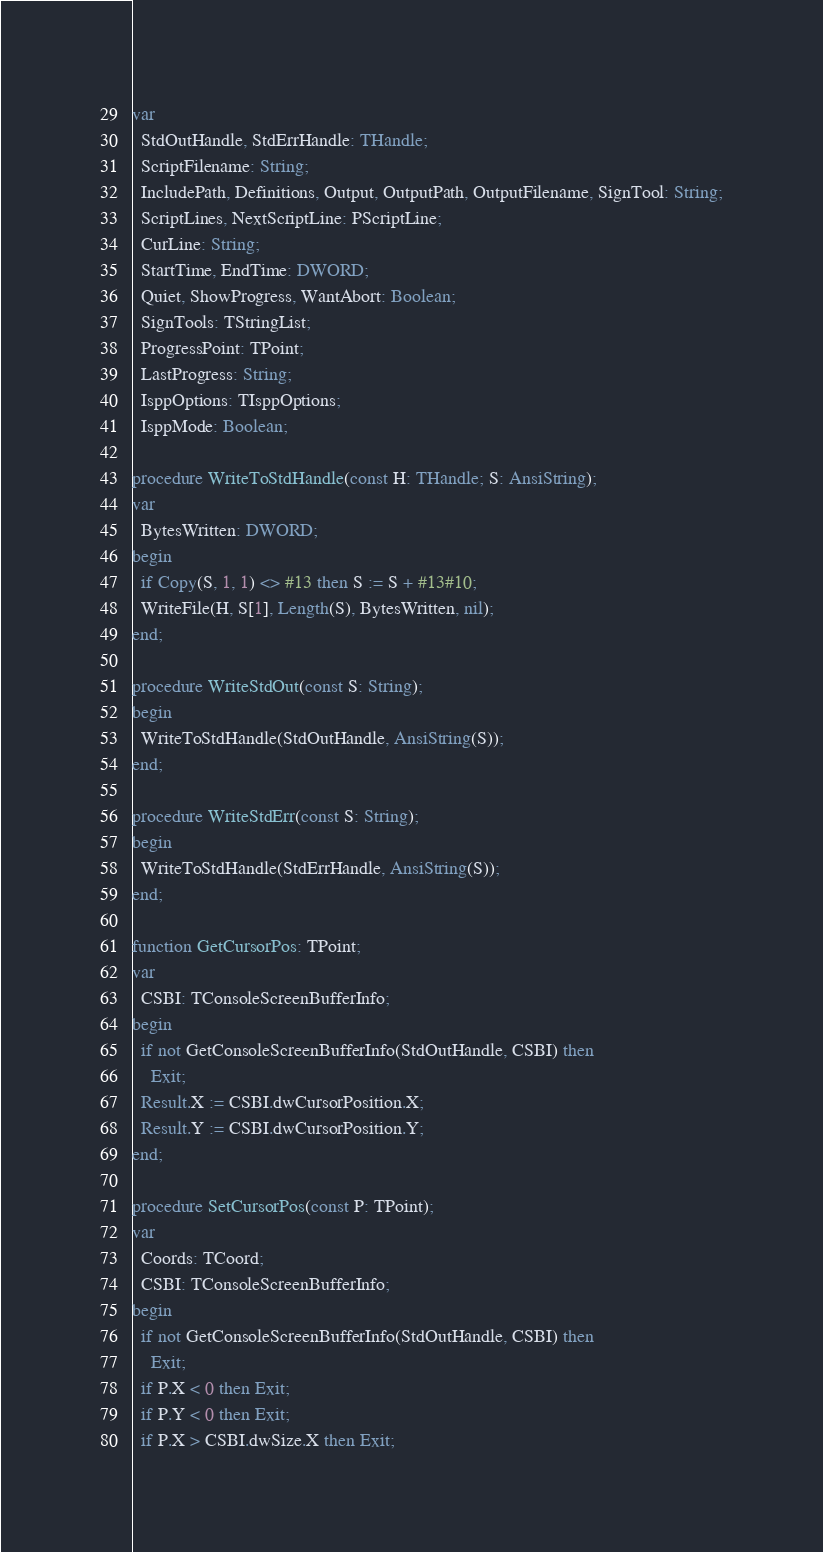Convert code to text. <code><loc_0><loc_0><loc_500><loc_500><_Pascal_>var
  StdOutHandle, StdErrHandle: THandle;
  ScriptFilename: String;
  IncludePath, Definitions, Output, OutputPath, OutputFilename, SignTool: String;
  ScriptLines, NextScriptLine: PScriptLine;
  CurLine: String;
  StartTime, EndTime: DWORD;
  Quiet, ShowProgress, WantAbort: Boolean;
  SignTools: TStringList;
  ProgressPoint: TPoint;
  LastProgress: String;
  IsppOptions: TIsppOptions;
  IsppMode: Boolean;

procedure WriteToStdHandle(const H: THandle; S: AnsiString);
var
  BytesWritten: DWORD;
begin
  if Copy(S, 1, 1) <> #13 then S := S + #13#10;
  WriteFile(H, S[1], Length(S), BytesWritten, nil);
end;

procedure WriteStdOut(const S: String);
begin
  WriteToStdHandle(StdOutHandle, AnsiString(S));
end;

procedure WriteStdErr(const S: String);
begin
  WriteToStdHandle(StdErrHandle, AnsiString(S));
end;

function GetCursorPos: TPoint;
var
  CSBI: TConsoleScreenBufferInfo;
begin
  if not GetConsoleScreenBufferInfo(StdOutHandle, CSBI) then
    Exit;
  Result.X := CSBI.dwCursorPosition.X;
  Result.Y := CSBI.dwCursorPosition.Y;
end;

procedure SetCursorPos(const P: TPoint);
var
  Coords: TCoord;
  CSBI: TConsoleScreenBufferInfo;
begin
  if not GetConsoleScreenBufferInfo(StdOutHandle, CSBI) then
    Exit;
  if P.X < 0 then Exit;
  if P.Y < 0 then Exit;
  if P.X > CSBI.dwSize.X then Exit;</code> 